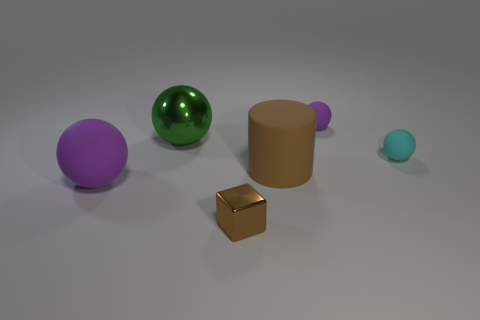Add 1 brown metallic objects. How many objects exist? 7 Subtract all cubes. How many objects are left? 5 Subtract 0 blue spheres. How many objects are left? 6 Subtract all red matte blocks. Subtract all cyan matte balls. How many objects are left? 5 Add 2 small spheres. How many small spheres are left? 4 Add 3 cyan matte things. How many cyan matte things exist? 4 